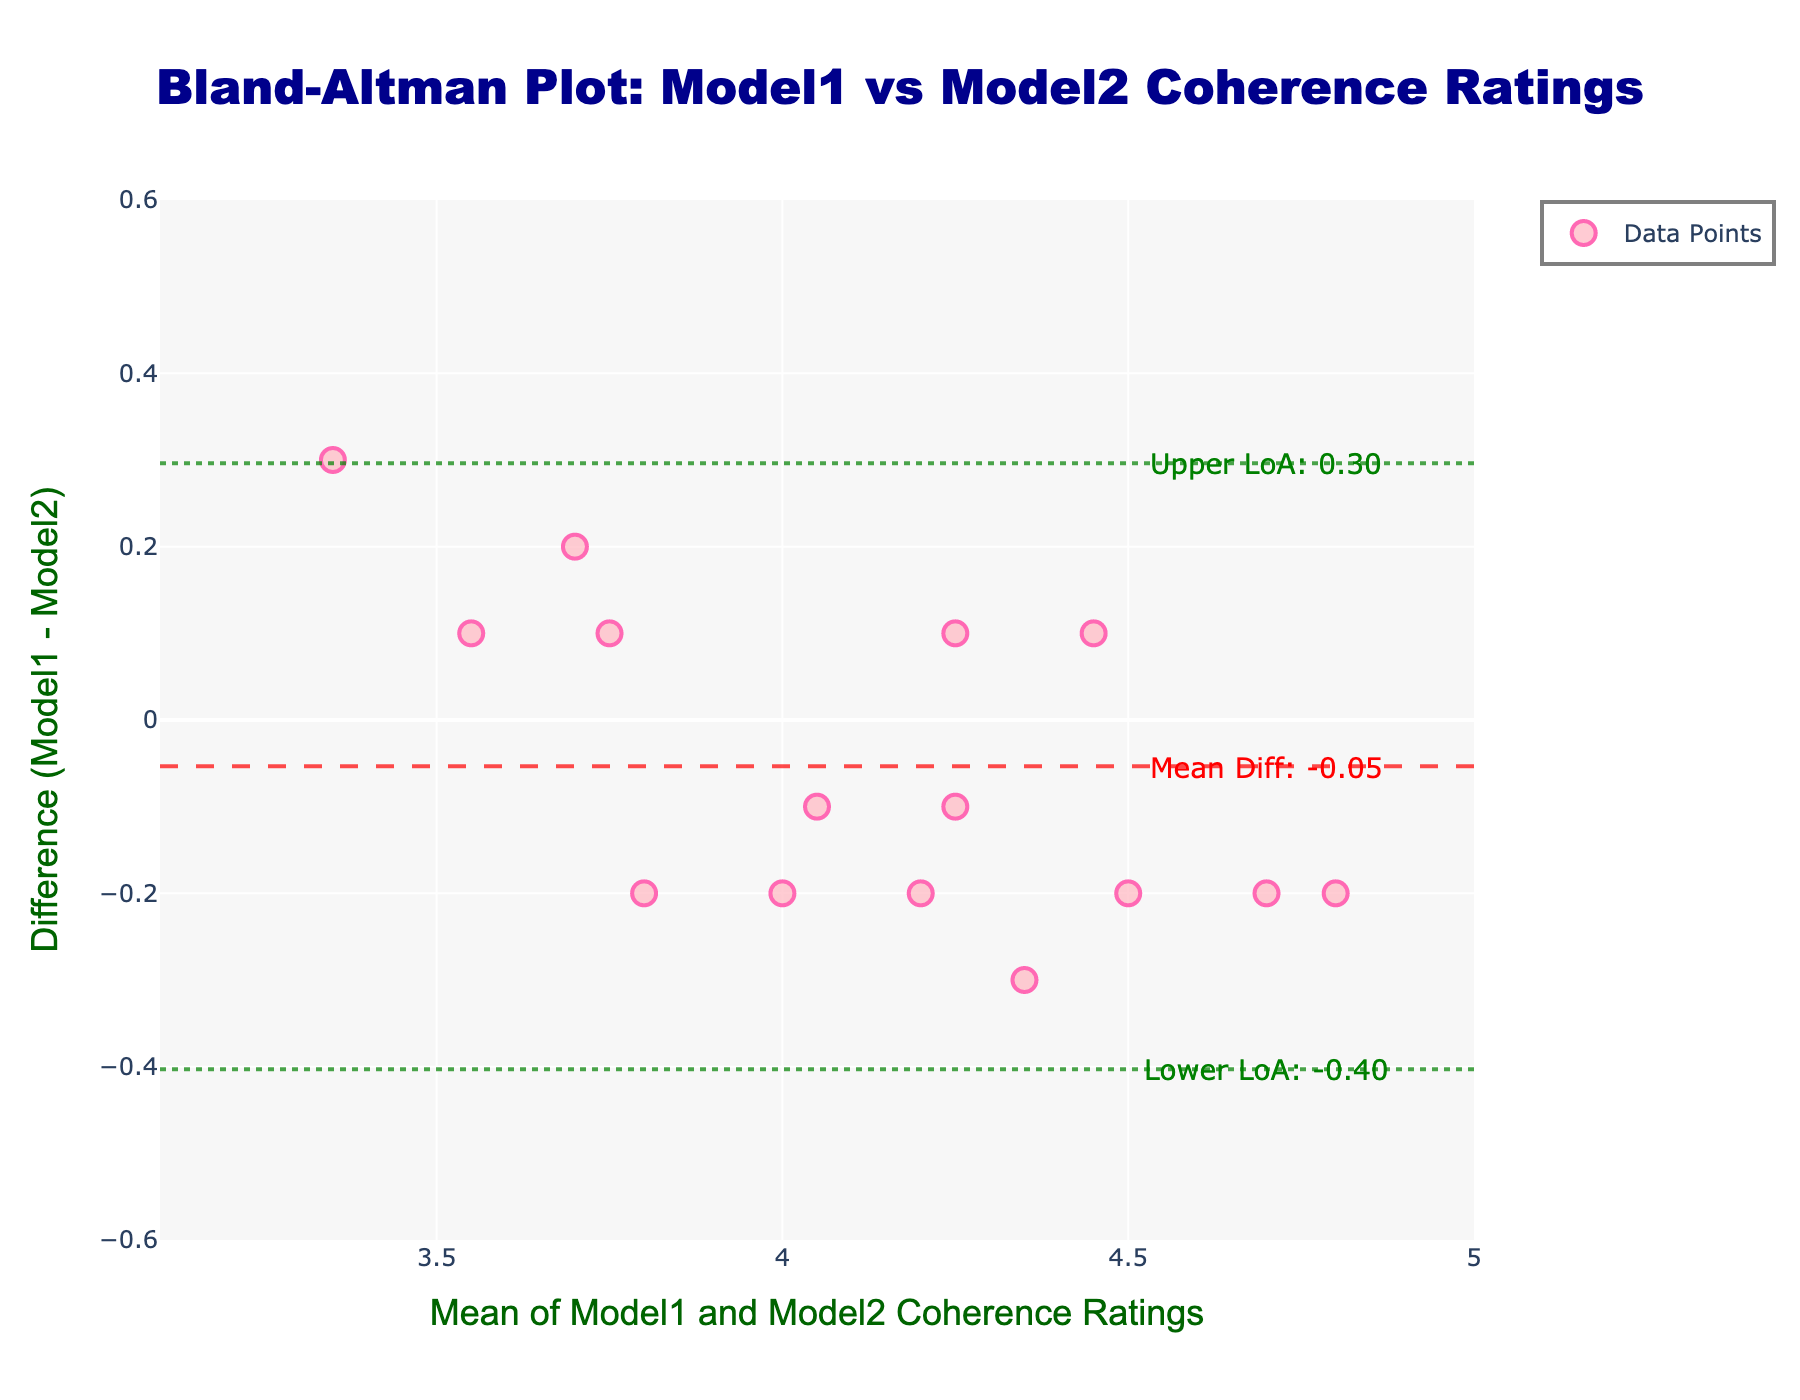How many data points are in the plot? You can count the number of dots (data points) on the plot directly to determine the total number.
Answer: 15 What color are the data points? The data points are stylized as dots, and they are pink with a red outline.
Answer: Pink with red outline What is the title of the plot? The title is positioned at the top of the plot and reads "Bland-Altman Plot: Model1 vs Model2 Coherence Ratings".
Answer: Bland-Altman Plot: Model1 vs Model2 Coherence Ratings What is the mean difference of the coherence ratings? The mean difference line is a dashed horizontal line with an annotation next to it stating "Mean Diff: 0.08".
Answer: 0.08 What are the limits of agreement in the plot? The limits of agreement (LoA) are shown as dashed lines and annotated with "Upper LoA: 0.29" and "Lower LoA: -0.14".
Answer: Upper LoA: 0.29, Lower LoA: -0.14 What is the range of the x-axis in the plot? The x-axis range can be seen from the axis tick marks, which range from approximately 3.1 to 5.0.
Answer: 3.1 to 5.0 What is the y-axis title of the plot? The y-axis title is displayed as "Difference (Model1 - Model2)" in a vertical orientation.
Answer: Difference (Model1 - Model2) How many data points lie above the mean difference line? By visually inspecting, count the number of data points above the dashed mean difference line.
Answer: 8 Between which coherence rating does the point at the mean value of 4.2 lie? Check the corresponding point at the x-value 4.2 and identify its y-value; since the plot represents differences, this point demonstrates the performance around the mean of 4.2.
Answer: Difference at 4.2 is approximately 0.2 (above mean difference) What does the y-axis range signify on this plot? The y-axis range of -0.6 to 0.6 represents the difference in coherence ratings between Model1 and Model2, indicating agreement levels.
Answer: -0.6 to 0.6 